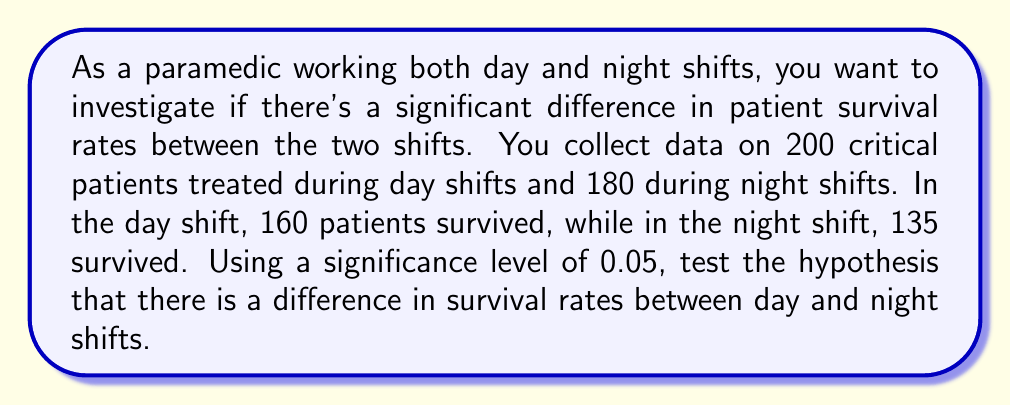Give your solution to this math problem. 1. Define the null and alternative hypotheses:
   $H_0: p_d = p_n$ (Day and night survival rates are equal)
   $H_a: p_d \neq p_n$ (Day and night survival rates are different)

2. Calculate the sample proportions:
   Day: $\hat{p}_d = \frac{160}{200} = 0.8$
   Night: $\hat{p}_n = \frac{135}{180} = 0.75$

3. Calculate the pooled proportion:
   $$\hat{p} = \frac{160 + 135}{200 + 180} = \frac{295}{380} \approx 0.7763$$

4. Calculate the standard error:
   $$SE = \sqrt{\hat{p}(1-\hat{p})(\frac{1}{n_d} + \frac{1}{n_n})}$$
   $$SE = \sqrt{0.7763(1-0.7763)(\frac{1}{200} + \frac{1}{180})} \approx 0.0431$$

5. Calculate the z-statistic:
   $$z = \frac{\hat{p}_d - \hat{p}_n}{SE} = \frac{0.8 - 0.75}{0.0431} \approx 1.1601$$

6. Find the critical value for a two-tailed test at α = 0.05:
   $z_{critical} = \pm 1.96$

7. Compare the z-statistic to the critical value:
   $|1.1601| < 1.96$

8. Calculate the p-value:
   $p-value = 2 * P(Z > 1.1601) \approx 0.2460$

9. Compare the p-value to the significance level:
   $0.2460 > 0.05$

Therefore, we fail to reject the null hypothesis. There is not enough evidence to conclude that there is a significant difference in survival rates between day and night shifts.
Answer: Fail to reject $H_0$; p-value = 0.2460 > 0.05 